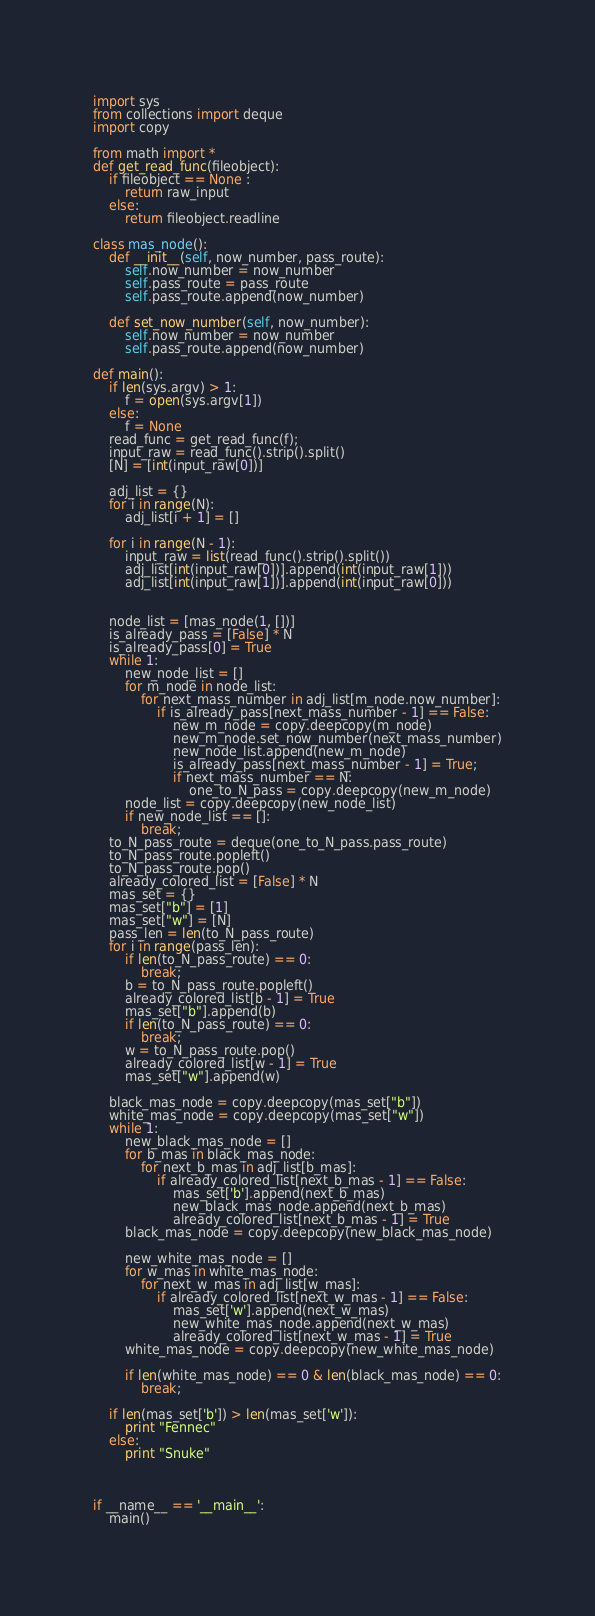<code> <loc_0><loc_0><loc_500><loc_500><_Python_>import sys
from collections import deque
import copy

from math import *
def get_read_func(fileobject):
    if fileobject == None :
        return raw_input
    else:
        return fileobject.readline

class mas_node():
    def __init__(self, now_number, pass_route):
        self.now_number = now_number
        self.pass_route = pass_route
        self.pass_route.append(now_number)

    def set_now_number(self, now_number):
        self.now_number = now_number
        self.pass_route.append(now_number)

def main():
    if len(sys.argv) > 1:
        f = open(sys.argv[1])
    else:
        f = None
    read_func = get_read_func(f);
    input_raw = read_func().strip().split()
    [N] = [int(input_raw[0])]

    adj_list = {}
    for i in range(N):
        adj_list[i + 1] = []

    for i in range(N - 1):
        input_raw = list(read_func().strip().split())
        adj_list[int(input_raw[0])].append(int(input_raw[1]))
        adj_list[int(input_raw[1])].append(int(input_raw[0]))


    node_list = [mas_node(1, [])]
    is_already_pass = [False] * N
    is_already_pass[0] = True
    while 1:
        new_node_list = []
        for m_node in node_list:
            for next_mass_number in adj_list[m_node.now_number]:
                if is_already_pass[next_mass_number - 1] == False:
                    new_m_node = copy.deepcopy(m_node)
                    new_m_node.set_now_number(next_mass_number)
                    new_node_list.append(new_m_node)
                    is_already_pass[next_mass_number - 1] = True;
                    if next_mass_number == N:
                        one_to_N_pass = copy.deepcopy(new_m_node)
        node_list = copy.deepcopy(new_node_list)
        if new_node_list == []:
            break;
    to_N_pass_route = deque(one_to_N_pass.pass_route)
    to_N_pass_route.popleft()
    to_N_pass_route.pop()
    already_colored_list = [False] * N
    mas_set = {}
    mas_set["b"] = [1]
    mas_set["w"] = [N]
    pass_len = len(to_N_pass_route)
    for i in range(pass_len):
        if len(to_N_pass_route) == 0:
            break;
        b = to_N_pass_route.popleft()
        already_colored_list[b - 1] = True
        mas_set["b"].append(b)
        if len(to_N_pass_route) == 0:
            break;
        w = to_N_pass_route.pop()
        already_colored_list[w - 1] = True
        mas_set["w"].append(w)

    black_mas_node = copy.deepcopy(mas_set["b"])
    white_mas_node = copy.deepcopy(mas_set["w"])
    while 1:
        new_black_mas_node = []
        for b_mas in black_mas_node:
            for next_b_mas in adj_list[b_mas]:
                if already_colored_list[next_b_mas - 1] == False:
                    mas_set['b'].append(next_b_mas)
                    new_black_mas_node.append(next_b_mas)
                    already_colored_list[next_b_mas - 1] = True
        black_mas_node = copy.deepcopy(new_black_mas_node)

        new_white_mas_node = []
        for w_mas in white_mas_node:
            for next_w_mas in adj_list[w_mas]:
                if already_colored_list[next_w_mas - 1] == False:
                    mas_set['w'].append(next_w_mas)
                    new_white_mas_node.append(next_w_mas)
                    already_colored_list[next_w_mas - 1] = True
        white_mas_node = copy.deepcopy(new_white_mas_node)

        if len(white_mas_node) == 0 & len(black_mas_node) == 0:
            break;

    if len(mas_set['b']) > len(mas_set['w']):
        print "Fennec"
    else:
        print "Snuke"



if __name__ == '__main__':
    main()</code> 